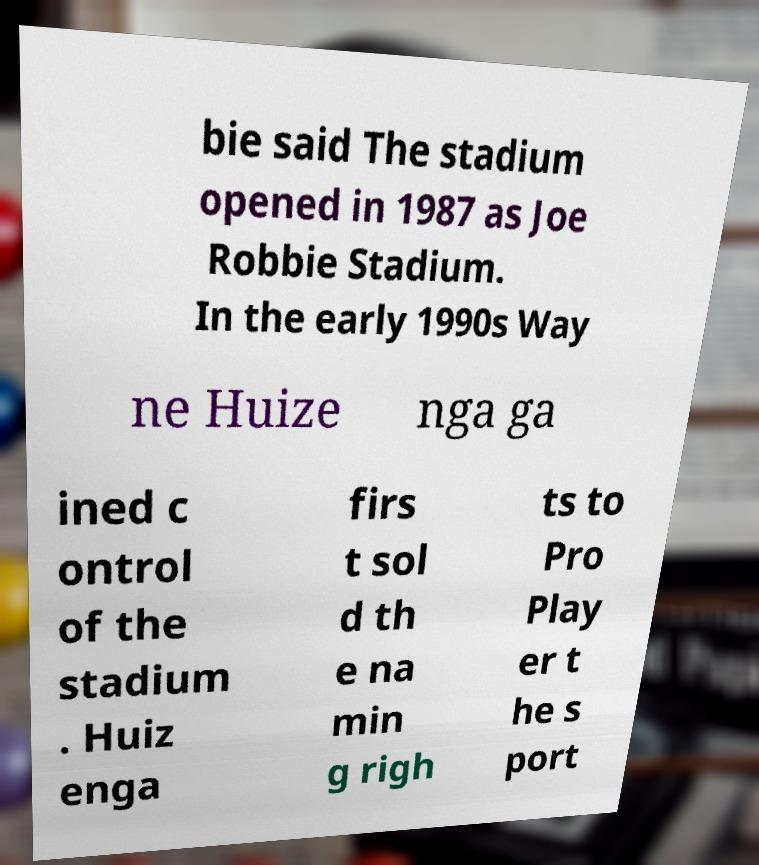Please identify and transcribe the text found in this image. bie said The stadium opened in 1987 as Joe Robbie Stadium. In the early 1990s Way ne Huize nga ga ined c ontrol of the stadium . Huiz enga firs t sol d th e na min g righ ts to Pro Play er t he s port 